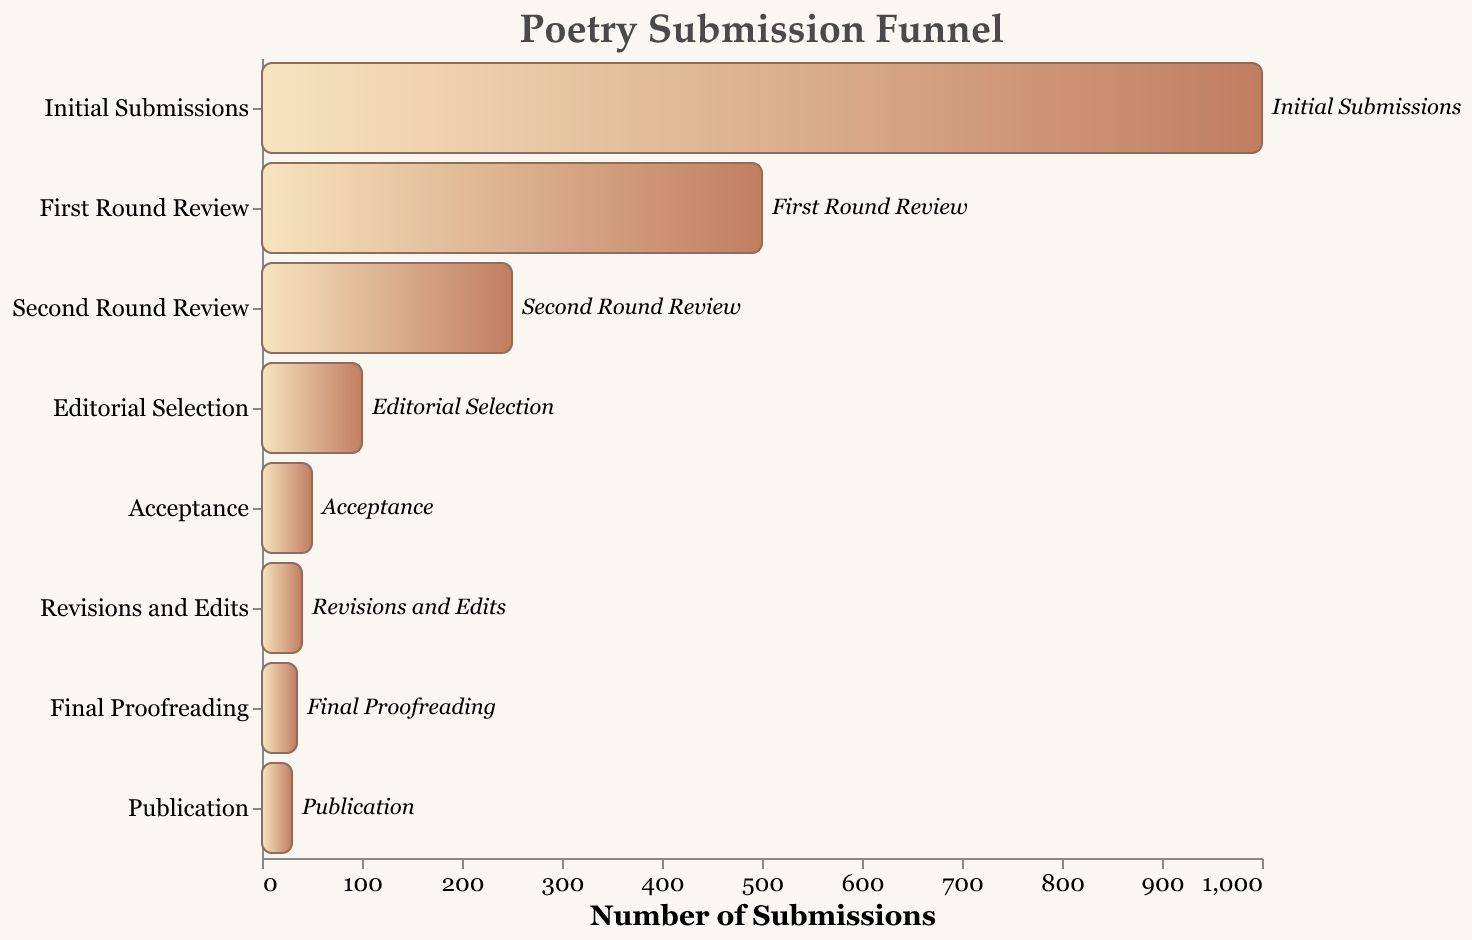What is the title of the funnel chart? The title is usually displayed at the top of the chart. In this case, it reads "Poetry Submission Funnel."
Answer: Poetry Submission Funnel Which stage has the highest number of submissions? Look at the bar corresponding to the "Initial Submissions" stage and see that it has the largest value, which is 1000.
Answer: Initial Submissions How many stages are in the poetry submission process shown in the funnel chart? Count the number of unique stages listed on the y-axis. There are 8 distinct stages.
Answer: 8 What is the difference in the number of submissions between the Initial Submissions and First Round Review stages? Subtract the number of submissions in the "First Round Review" stage (500) from the "Initial Submissions" stage (1000). 1000 - 500 = 500.
Answer: 500 At which stage do half the initial submissions get filtered out? The "First Round Review" shows a decrease to half of the "Initial Submissions" (from 1000 to 500).
Answer: First Round Review What is the percentage drop in the number of submissions from the Initial Submissions to the Publication stage? Calculate as follows: ((1000 - 30) / 1000) * 100 = 97%.
Answer: 97% Which stages see less than 100 submissions each? Look at the bars for the stages and find that the "Acceptance," "Revisions and Edits," "Final Proofreading," and "Publication" stages all have fewer than 100 submissions.
Answer: Acceptance, Revisions and Edits, Final Proofreading, Publication What is the ratio of the number of submissions in the Editorial Selection to those in the First Round Review? Divide the number of submissions in "Editorial Selection" (100) by those in the "First Round Review" (500). This results in 100 / 500 = 1/5 or 0.2.
Answer: 0.2 Between which two successive stages is the greatest drop in the number of submissions? Compare the differences between successive stages: Initial Submissions to First Round Review (500), First Round Review to Second Round Review (250), Second Round Review to Editorial Selection (150), Editorial Selection to Acceptance (50), Acceptance to Revisions and Edits (10), Revisions and Edits to Final Proofreading (5), Final Proofreading to Publication (5). The largest drop is from Initial Submissions to First Round Review, which is 500.
Answer: Initial Submissions to First Round Review How many submissions make it from the First Round Review to the next stage? Look at the number of submissions between "First Round Review" and "Second Round Review." It drops from 500 to 250.
Answer: 250 